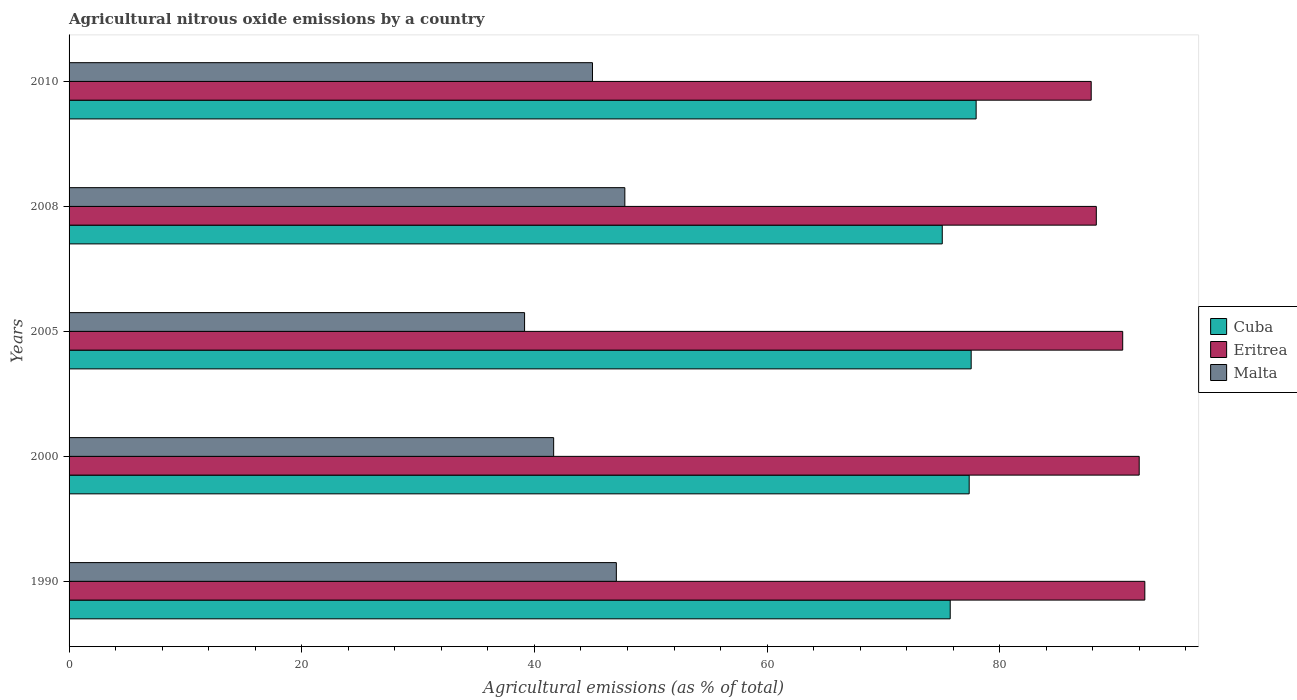Are the number of bars on each tick of the Y-axis equal?
Provide a short and direct response. Yes. In how many cases, is the number of bars for a given year not equal to the number of legend labels?
Your answer should be compact. 0. What is the amount of agricultural nitrous oxide emitted in Cuba in 1990?
Make the answer very short. 75.74. Across all years, what is the maximum amount of agricultural nitrous oxide emitted in Eritrea?
Your answer should be compact. 92.47. Across all years, what is the minimum amount of agricultural nitrous oxide emitted in Malta?
Offer a very short reply. 39.15. In which year was the amount of agricultural nitrous oxide emitted in Malta maximum?
Keep it short and to the point. 2008. In which year was the amount of agricultural nitrous oxide emitted in Malta minimum?
Your answer should be compact. 2005. What is the total amount of agricultural nitrous oxide emitted in Cuba in the graph?
Your answer should be very brief. 383.69. What is the difference between the amount of agricultural nitrous oxide emitted in Malta in 2000 and that in 2005?
Provide a succinct answer. 2.5. What is the difference between the amount of agricultural nitrous oxide emitted in Cuba in 1990 and the amount of agricultural nitrous oxide emitted in Eritrea in 2008?
Provide a short and direct response. -12.56. What is the average amount of agricultural nitrous oxide emitted in Cuba per year?
Provide a succinct answer. 76.74. In the year 2010, what is the difference between the amount of agricultural nitrous oxide emitted in Eritrea and amount of agricultural nitrous oxide emitted in Cuba?
Ensure brevity in your answer.  9.89. In how many years, is the amount of agricultural nitrous oxide emitted in Cuba greater than 20 %?
Your answer should be compact. 5. What is the ratio of the amount of agricultural nitrous oxide emitted in Eritrea in 2000 to that in 2008?
Keep it short and to the point. 1.04. What is the difference between the highest and the second highest amount of agricultural nitrous oxide emitted in Cuba?
Make the answer very short. 0.43. What is the difference between the highest and the lowest amount of agricultural nitrous oxide emitted in Malta?
Offer a terse response. 8.62. In how many years, is the amount of agricultural nitrous oxide emitted in Malta greater than the average amount of agricultural nitrous oxide emitted in Malta taken over all years?
Offer a very short reply. 3. What does the 1st bar from the top in 2000 represents?
Offer a very short reply. Malta. What does the 2nd bar from the bottom in 2010 represents?
Make the answer very short. Eritrea. Is it the case that in every year, the sum of the amount of agricultural nitrous oxide emitted in Malta and amount of agricultural nitrous oxide emitted in Eritrea is greater than the amount of agricultural nitrous oxide emitted in Cuba?
Make the answer very short. Yes. Are all the bars in the graph horizontal?
Give a very brief answer. Yes. What is the difference between two consecutive major ticks on the X-axis?
Give a very brief answer. 20. Are the values on the major ticks of X-axis written in scientific E-notation?
Provide a succinct answer. No. Does the graph contain grids?
Offer a terse response. No. Where does the legend appear in the graph?
Give a very brief answer. Center right. How are the legend labels stacked?
Offer a very short reply. Vertical. What is the title of the graph?
Offer a terse response. Agricultural nitrous oxide emissions by a country. Does "Bosnia and Herzegovina" appear as one of the legend labels in the graph?
Offer a terse response. No. What is the label or title of the X-axis?
Your response must be concise. Agricultural emissions (as % of total). What is the Agricultural emissions (as % of total) of Cuba in 1990?
Offer a terse response. 75.74. What is the Agricultural emissions (as % of total) of Eritrea in 1990?
Make the answer very short. 92.47. What is the Agricultural emissions (as % of total) of Malta in 1990?
Offer a terse response. 47.04. What is the Agricultural emissions (as % of total) in Cuba in 2000?
Provide a succinct answer. 77.37. What is the Agricultural emissions (as % of total) in Eritrea in 2000?
Keep it short and to the point. 91.99. What is the Agricultural emissions (as % of total) of Malta in 2000?
Provide a short and direct response. 41.65. What is the Agricultural emissions (as % of total) in Cuba in 2005?
Offer a terse response. 77.54. What is the Agricultural emissions (as % of total) of Eritrea in 2005?
Offer a terse response. 90.57. What is the Agricultural emissions (as % of total) of Malta in 2005?
Provide a short and direct response. 39.15. What is the Agricultural emissions (as % of total) of Cuba in 2008?
Provide a short and direct response. 75.06. What is the Agricultural emissions (as % of total) in Eritrea in 2008?
Your response must be concise. 88.3. What is the Agricultural emissions (as % of total) of Malta in 2008?
Make the answer very short. 47.77. What is the Agricultural emissions (as % of total) of Cuba in 2010?
Give a very brief answer. 77.97. What is the Agricultural emissions (as % of total) of Eritrea in 2010?
Make the answer very short. 87.86. What is the Agricultural emissions (as % of total) in Malta in 2010?
Your answer should be compact. 44.99. Across all years, what is the maximum Agricultural emissions (as % of total) of Cuba?
Offer a terse response. 77.97. Across all years, what is the maximum Agricultural emissions (as % of total) of Eritrea?
Keep it short and to the point. 92.47. Across all years, what is the maximum Agricultural emissions (as % of total) of Malta?
Give a very brief answer. 47.77. Across all years, what is the minimum Agricultural emissions (as % of total) in Cuba?
Your response must be concise. 75.06. Across all years, what is the minimum Agricultural emissions (as % of total) in Eritrea?
Your answer should be very brief. 87.86. Across all years, what is the minimum Agricultural emissions (as % of total) in Malta?
Provide a short and direct response. 39.15. What is the total Agricultural emissions (as % of total) of Cuba in the graph?
Your answer should be very brief. 383.69. What is the total Agricultural emissions (as % of total) of Eritrea in the graph?
Keep it short and to the point. 451.19. What is the total Agricultural emissions (as % of total) of Malta in the graph?
Provide a short and direct response. 220.62. What is the difference between the Agricultural emissions (as % of total) in Cuba in 1990 and that in 2000?
Make the answer very short. -1.63. What is the difference between the Agricultural emissions (as % of total) in Eritrea in 1990 and that in 2000?
Your answer should be very brief. 0.48. What is the difference between the Agricultural emissions (as % of total) in Malta in 1990 and that in 2000?
Provide a succinct answer. 5.39. What is the difference between the Agricultural emissions (as % of total) in Cuba in 1990 and that in 2005?
Your answer should be compact. -1.8. What is the difference between the Agricultural emissions (as % of total) in Eritrea in 1990 and that in 2005?
Provide a succinct answer. 1.9. What is the difference between the Agricultural emissions (as % of total) of Malta in 1990 and that in 2005?
Ensure brevity in your answer.  7.89. What is the difference between the Agricultural emissions (as % of total) in Cuba in 1990 and that in 2008?
Your response must be concise. 0.68. What is the difference between the Agricultural emissions (as % of total) of Eritrea in 1990 and that in 2008?
Provide a succinct answer. 4.17. What is the difference between the Agricultural emissions (as % of total) in Malta in 1990 and that in 2008?
Offer a very short reply. -0.73. What is the difference between the Agricultural emissions (as % of total) of Cuba in 1990 and that in 2010?
Make the answer very short. -2.23. What is the difference between the Agricultural emissions (as % of total) in Eritrea in 1990 and that in 2010?
Make the answer very short. 4.61. What is the difference between the Agricultural emissions (as % of total) of Malta in 1990 and that in 2010?
Offer a very short reply. 2.05. What is the difference between the Agricultural emissions (as % of total) in Cuba in 2000 and that in 2005?
Offer a terse response. -0.17. What is the difference between the Agricultural emissions (as % of total) in Eritrea in 2000 and that in 2005?
Your answer should be compact. 1.42. What is the difference between the Agricultural emissions (as % of total) in Malta in 2000 and that in 2005?
Give a very brief answer. 2.5. What is the difference between the Agricultural emissions (as % of total) in Cuba in 2000 and that in 2008?
Make the answer very short. 2.31. What is the difference between the Agricultural emissions (as % of total) in Eritrea in 2000 and that in 2008?
Your answer should be compact. 3.69. What is the difference between the Agricultural emissions (as % of total) of Malta in 2000 and that in 2008?
Ensure brevity in your answer.  -6.12. What is the difference between the Agricultural emissions (as % of total) of Cuba in 2000 and that in 2010?
Provide a short and direct response. -0.6. What is the difference between the Agricultural emissions (as % of total) in Eritrea in 2000 and that in 2010?
Offer a terse response. 4.13. What is the difference between the Agricultural emissions (as % of total) in Malta in 2000 and that in 2010?
Give a very brief answer. -3.34. What is the difference between the Agricultural emissions (as % of total) of Cuba in 2005 and that in 2008?
Make the answer very short. 2.48. What is the difference between the Agricultural emissions (as % of total) in Eritrea in 2005 and that in 2008?
Keep it short and to the point. 2.27. What is the difference between the Agricultural emissions (as % of total) of Malta in 2005 and that in 2008?
Provide a short and direct response. -8.62. What is the difference between the Agricultural emissions (as % of total) of Cuba in 2005 and that in 2010?
Keep it short and to the point. -0.43. What is the difference between the Agricultural emissions (as % of total) of Eritrea in 2005 and that in 2010?
Make the answer very short. 2.71. What is the difference between the Agricultural emissions (as % of total) in Malta in 2005 and that in 2010?
Make the answer very short. -5.84. What is the difference between the Agricultural emissions (as % of total) in Cuba in 2008 and that in 2010?
Provide a short and direct response. -2.91. What is the difference between the Agricultural emissions (as % of total) of Eritrea in 2008 and that in 2010?
Your response must be concise. 0.44. What is the difference between the Agricultural emissions (as % of total) in Malta in 2008 and that in 2010?
Offer a very short reply. 2.78. What is the difference between the Agricultural emissions (as % of total) in Cuba in 1990 and the Agricultural emissions (as % of total) in Eritrea in 2000?
Keep it short and to the point. -16.24. What is the difference between the Agricultural emissions (as % of total) in Cuba in 1990 and the Agricultural emissions (as % of total) in Malta in 2000?
Provide a succinct answer. 34.09. What is the difference between the Agricultural emissions (as % of total) in Eritrea in 1990 and the Agricultural emissions (as % of total) in Malta in 2000?
Offer a terse response. 50.82. What is the difference between the Agricultural emissions (as % of total) in Cuba in 1990 and the Agricultural emissions (as % of total) in Eritrea in 2005?
Offer a very short reply. -14.83. What is the difference between the Agricultural emissions (as % of total) in Cuba in 1990 and the Agricultural emissions (as % of total) in Malta in 2005?
Your answer should be very brief. 36.59. What is the difference between the Agricultural emissions (as % of total) of Eritrea in 1990 and the Agricultural emissions (as % of total) of Malta in 2005?
Your response must be concise. 53.32. What is the difference between the Agricultural emissions (as % of total) in Cuba in 1990 and the Agricultural emissions (as % of total) in Eritrea in 2008?
Make the answer very short. -12.56. What is the difference between the Agricultural emissions (as % of total) in Cuba in 1990 and the Agricultural emissions (as % of total) in Malta in 2008?
Provide a short and direct response. 27.97. What is the difference between the Agricultural emissions (as % of total) in Eritrea in 1990 and the Agricultural emissions (as % of total) in Malta in 2008?
Make the answer very short. 44.7. What is the difference between the Agricultural emissions (as % of total) in Cuba in 1990 and the Agricultural emissions (as % of total) in Eritrea in 2010?
Provide a succinct answer. -12.12. What is the difference between the Agricultural emissions (as % of total) in Cuba in 1990 and the Agricultural emissions (as % of total) in Malta in 2010?
Offer a very short reply. 30.75. What is the difference between the Agricultural emissions (as % of total) of Eritrea in 1990 and the Agricultural emissions (as % of total) of Malta in 2010?
Make the answer very short. 47.48. What is the difference between the Agricultural emissions (as % of total) of Cuba in 2000 and the Agricultural emissions (as % of total) of Eritrea in 2005?
Make the answer very short. -13.2. What is the difference between the Agricultural emissions (as % of total) in Cuba in 2000 and the Agricultural emissions (as % of total) in Malta in 2005?
Give a very brief answer. 38.22. What is the difference between the Agricultural emissions (as % of total) in Eritrea in 2000 and the Agricultural emissions (as % of total) in Malta in 2005?
Keep it short and to the point. 52.83. What is the difference between the Agricultural emissions (as % of total) in Cuba in 2000 and the Agricultural emissions (as % of total) in Eritrea in 2008?
Offer a very short reply. -10.93. What is the difference between the Agricultural emissions (as % of total) in Cuba in 2000 and the Agricultural emissions (as % of total) in Malta in 2008?
Offer a very short reply. 29.6. What is the difference between the Agricultural emissions (as % of total) of Eritrea in 2000 and the Agricultural emissions (as % of total) of Malta in 2008?
Provide a short and direct response. 44.21. What is the difference between the Agricultural emissions (as % of total) in Cuba in 2000 and the Agricultural emissions (as % of total) in Eritrea in 2010?
Offer a terse response. -10.49. What is the difference between the Agricultural emissions (as % of total) of Cuba in 2000 and the Agricultural emissions (as % of total) of Malta in 2010?
Provide a short and direct response. 32.38. What is the difference between the Agricultural emissions (as % of total) in Eritrea in 2000 and the Agricultural emissions (as % of total) in Malta in 2010?
Offer a terse response. 47. What is the difference between the Agricultural emissions (as % of total) of Cuba in 2005 and the Agricultural emissions (as % of total) of Eritrea in 2008?
Provide a succinct answer. -10.76. What is the difference between the Agricultural emissions (as % of total) of Cuba in 2005 and the Agricultural emissions (as % of total) of Malta in 2008?
Your response must be concise. 29.77. What is the difference between the Agricultural emissions (as % of total) in Eritrea in 2005 and the Agricultural emissions (as % of total) in Malta in 2008?
Keep it short and to the point. 42.8. What is the difference between the Agricultural emissions (as % of total) of Cuba in 2005 and the Agricultural emissions (as % of total) of Eritrea in 2010?
Provide a short and direct response. -10.32. What is the difference between the Agricultural emissions (as % of total) of Cuba in 2005 and the Agricultural emissions (as % of total) of Malta in 2010?
Provide a short and direct response. 32.55. What is the difference between the Agricultural emissions (as % of total) in Eritrea in 2005 and the Agricultural emissions (as % of total) in Malta in 2010?
Offer a very short reply. 45.58. What is the difference between the Agricultural emissions (as % of total) of Cuba in 2008 and the Agricultural emissions (as % of total) of Eritrea in 2010?
Ensure brevity in your answer.  -12.8. What is the difference between the Agricultural emissions (as % of total) of Cuba in 2008 and the Agricultural emissions (as % of total) of Malta in 2010?
Your answer should be compact. 30.07. What is the difference between the Agricultural emissions (as % of total) in Eritrea in 2008 and the Agricultural emissions (as % of total) in Malta in 2010?
Provide a succinct answer. 43.31. What is the average Agricultural emissions (as % of total) of Cuba per year?
Your answer should be very brief. 76.74. What is the average Agricultural emissions (as % of total) in Eritrea per year?
Offer a terse response. 90.24. What is the average Agricultural emissions (as % of total) in Malta per year?
Provide a short and direct response. 44.12. In the year 1990, what is the difference between the Agricultural emissions (as % of total) in Cuba and Agricultural emissions (as % of total) in Eritrea?
Offer a very short reply. -16.73. In the year 1990, what is the difference between the Agricultural emissions (as % of total) of Cuba and Agricultural emissions (as % of total) of Malta?
Give a very brief answer. 28.7. In the year 1990, what is the difference between the Agricultural emissions (as % of total) in Eritrea and Agricultural emissions (as % of total) in Malta?
Offer a terse response. 45.43. In the year 2000, what is the difference between the Agricultural emissions (as % of total) in Cuba and Agricultural emissions (as % of total) in Eritrea?
Keep it short and to the point. -14.62. In the year 2000, what is the difference between the Agricultural emissions (as % of total) in Cuba and Agricultural emissions (as % of total) in Malta?
Your answer should be compact. 35.72. In the year 2000, what is the difference between the Agricultural emissions (as % of total) in Eritrea and Agricultural emissions (as % of total) in Malta?
Your response must be concise. 50.33. In the year 2005, what is the difference between the Agricultural emissions (as % of total) in Cuba and Agricultural emissions (as % of total) in Eritrea?
Offer a very short reply. -13.02. In the year 2005, what is the difference between the Agricultural emissions (as % of total) of Cuba and Agricultural emissions (as % of total) of Malta?
Make the answer very short. 38.39. In the year 2005, what is the difference between the Agricultural emissions (as % of total) of Eritrea and Agricultural emissions (as % of total) of Malta?
Your response must be concise. 51.41. In the year 2008, what is the difference between the Agricultural emissions (as % of total) in Cuba and Agricultural emissions (as % of total) in Eritrea?
Offer a very short reply. -13.24. In the year 2008, what is the difference between the Agricultural emissions (as % of total) in Cuba and Agricultural emissions (as % of total) in Malta?
Offer a terse response. 27.29. In the year 2008, what is the difference between the Agricultural emissions (as % of total) in Eritrea and Agricultural emissions (as % of total) in Malta?
Make the answer very short. 40.53. In the year 2010, what is the difference between the Agricultural emissions (as % of total) in Cuba and Agricultural emissions (as % of total) in Eritrea?
Offer a very short reply. -9.89. In the year 2010, what is the difference between the Agricultural emissions (as % of total) in Cuba and Agricultural emissions (as % of total) in Malta?
Offer a very short reply. 32.98. In the year 2010, what is the difference between the Agricultural emissions (as % of total) in Eritrea and Agricultural emissions (as % of total) in Malta?
Your answer should be compact. 42.87. What is the ratio of the Agricultural emissions (as % of total) of Cuba in 1990 to that in 2000?
Give a very brief answer. 0.98. What is the ratio of the Agricultural emissions (as % of total) of Malta in 1990 to that in 2000?
Make the answer very short. 1.13. What is the ratio of the Agricultural emissions (as % of total) in Cuba in 1990 to that in 2005?
Your response must be concise. 0.98. What is the ratio of the Agricultural emissions (as % of total) of Eritrea in 1990 to that in 2005?
Offer a very short reply. 1.02. What is the ratio of the Agricultural emissions (as % of total) of Malta in 1990 to that in 2005?
Your answer should be compact. 1.2. What is the ratio of the Agricultural emissions (as % of total) of Cuba in 1990 to that in 2008?
Offer a terse response. 1.01. What is the ratio of the Agricultural emissions (as % of total) in Eritrea in 1990 to that in 2008?
Your response must be concise. 1.05. What is the ratio of the Agricultural emissions (as % of total) in Malta in 1990 to that in 2008?
Provide a short and direct response. 0.98. What is the ratio of the Agricultural emissions (as % of total) in Cuba in 1990 to that in 2010?
Provide a succinct answer. 0.97. What is the ratio of the Agricultural emissions (as % of total) in Eritrea in 1990 to that in 2010?
Offer a very short reply. 1.05. What is the ratio of the Agricultural emissions (as % of total) of Malta in 1990 to that in 2010?
Make the answer very short. 1.05. What is the ratio of the Agricultural emissions (as % of total) in Cuba in 2000 to that in 2005?
Ensure brevity in your answer.  1. What is the ratio of the Agricultural emissions (as % of total) of Eritrea in 2000 to that in 2005?
Provide a short and direct response. 1.02. What is the ratio of the Agricultural emissions (as % of total) of Malta in 2000 to that in 2005?
Your answer should be very brief. 1.06. What is the ratio of the Agricultural emissions (as % of total) of Cuba in 2000 to that in 2008?
Your response must be concise. 1.03. What is the ratio of the Agricultural emissions (as % of total) in Eritrea in 2000 to that in 2008?
Give a very brief answer. 1.04. What is the ratio of the Agricultural emissions (as % of total) in Malta in 2000 to that in 2008?
Give a very brief answer. 0.87. What is the ratio of the Agricultural emissions (as % of total) in Eritrea in 2000 to that in 2010?
Provide a succinct answer. 1.05. What is the ratio of the Agricultural emissions (as % of total) of Malta in 2000 to that in 2010?
Give a very brief answer. 0.93. What is the ratio of the Agricultural emissions (as % of total) of Cuba in 2005 to that in 2008?
Your response must be concise. 1.03. What is the ratio of the Agricultural emissions (as % of total) in Eritrea in 2005 to that in 2008?
Your response must be concise. 1.03. What is the ratio of the Agricultural emissions (as % of total) in Malta in 2005 to that in 2008?
Keep it short and to the point. 0.82. What is the ratio of the Agricultural emissions (as % of total) of Eritrea in 2005 to that in 2010?
Your response must be concise. 1.03. What is the ratio of the Agricultural emissions (as % of total) in Malta in 2005 to that in 2010?
Give a very brief answer. 0.87. What is the ratio of the Agricultural emissions (as % of total) in Cuba in 2008 to that in 2010?
Make the answer very short. 0.96. What is the ratio of the Agricultural emissions (as % of total) of Malta in 2008 to that in 2010?
Provide a short and direct response. 1.06. What is the difference between the highest and the second highest Agricultural emissions (as % of total) in Cuba?
Make the answer very short. 0.43. What is the difference between the highest and the second highest Agricultural emissions (as % of total) of Eritrea?
Your answer should be compact. 0.48. What is the difference between the highest and the second highest Agricultural emissions (as % of total) in Malta?
Make the answer very short. 0.73. What is the difference between the highest and the lowest Agricultural emissions (as % of total) in Cuba?
Your answer should be very brief. 2.91. What is the difference between the highest and the lowest Agricultural emissions (as % of total) of Eritrea?
Your answer should be very brief. 4.61. What is the difference between the highest and the lowest Agricultural emissions (as % of total) in Malta?
Make the answer very short. 8.62. 